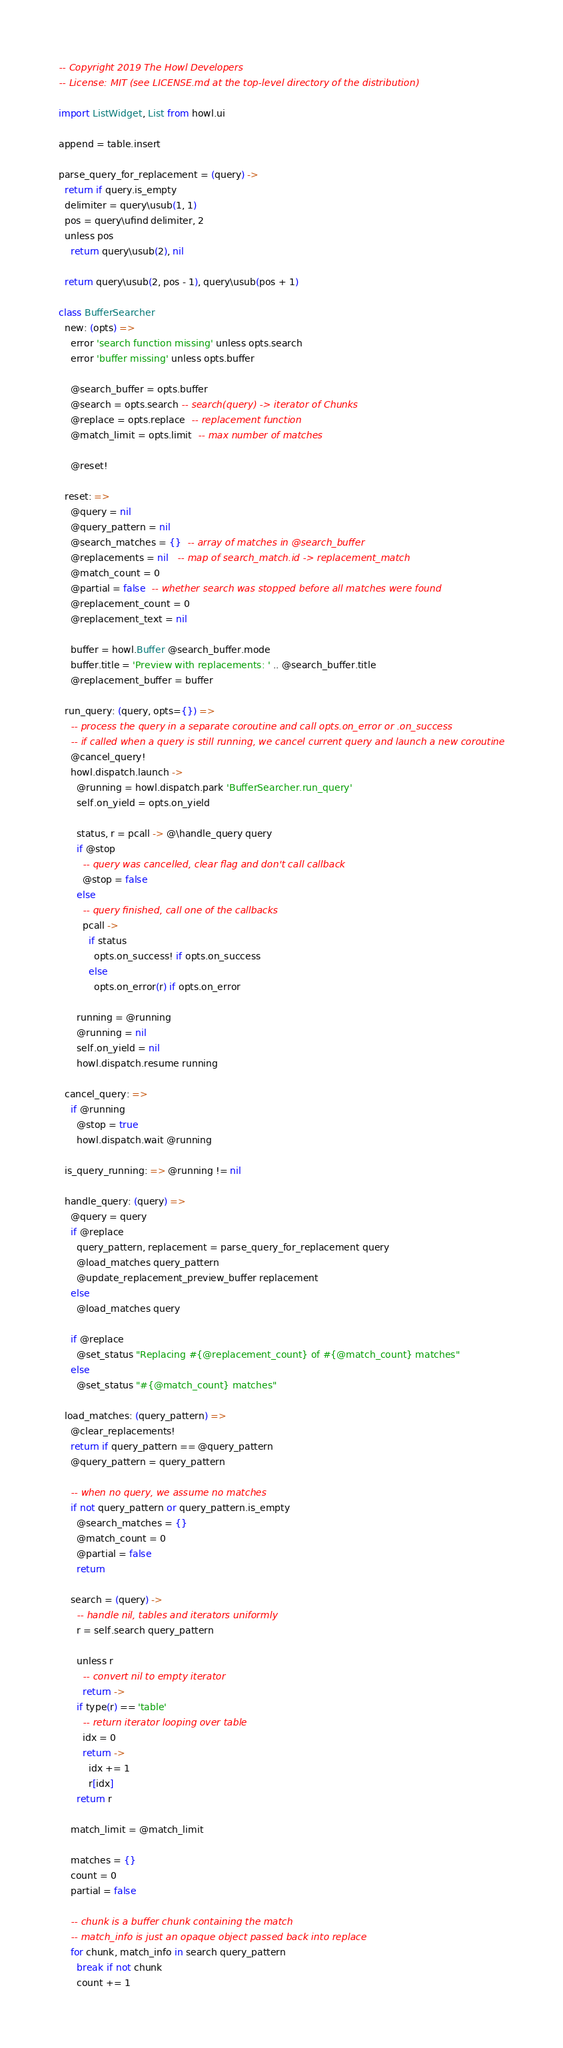Convert code to text. <code><loc_0><loc_0><loc_500><loc_500><_MoonScript_>-- Copyright 2019 The Howl Developers
-- License: MIT (see LICENSE.md at the top-level directory of the distribution)

import ListWidget, List from howl.ui

append = table.insert

parse_query_for_replacement = (query) ->
  return if query.is_empty
  delimiter = query\usub(1, 1)
  pos = query\ufind delimiter, 2
  unless pos
    return query\usub(2), nil

  return query\usub(2, pos - 1), query\usub(pos + 1)

class BufferSearcher
  new: (opts) =>
    error 'search function missing' unless opts.search
    error 'buffer missing' unless opts.buffer

    @search_buffer = opts.buffer
    @search = opts.search -- search(query) -> iterator of Chunks
    @replace = opts.replace  -- replacement function
    @match_limit = opts.limit  -- max number of matches

    @reset!

  reset: =>
    @query = nil
    @query_pattern = nil
    @search_matches = {}  -- array of matches in @search_buffer
    @replacements = nil   -- map of search_match.id -> replacement_match
    @match_count = 0
    @partial = false  -- whether search was stopped before all matches were found
    @replacement_count = 0
    @replacement_text = nil

    buffer = howl.Buffer @search_buffer.mode
    buffer.title = 'Preview with replacements: ' .. @search_buffer.title
    @replacement_buffer = buffer

  run_query: (query, opts={}) =>
    -- process the query in a separate coroutine and call opts.on_error or .on_success
    -- if called when a query is still running, we cancel current query and launch a new coroutine
    @cancel_query!
    howl.dispatch.launch ->
      @running = howl.dispatch.park 'BufferSearcher.run_query'
      self.on_yield = opts.on_yield

      status, r = pcall -> @\handle_query query
      if @stop
        -- query was cancelled, clear flag and don't call callback
        @stop = false
      else
        -- query finished, call one of the callbacks
        pcall ->
          if status
            opts.on_success! if opts.on_success
          else
            opts.on_error(r) if opts.on_error

      running = @running
      @running = nil
      self.on_yield = nil
      howl.dispatch.resume running

  cancel_query: =>
    if @running
      @stop = true
      howl.dispatch.wait @running

  is_query_running: => @running != nil

  handle_query: (query) =>
    @query = query
    if @replace
      query_pattern, replacement = parse_query_for_replacement query
      @load_matches query_pattern
      @update_replacement_preview_buffer replacement
    else
      @load_matches query

    if @replace
      @set_status "Replacing #{@replacement_count} of #{@match_count} matches"
    else
      @set_status "#{@match_count} matches"

  load_matches: (query_pattern) =>
    @clear_replacements!
    return if query_pattern == @query_pattern
    @query_pattern = query_pattern

    -- when no query, we assume no matches
    if not query_pattern or query_pattern.is_empty
      @search_matches = {}
      @match_count = 0
      @partial = false
      return

    search = (query) ->
      -- handle nil, tables and iterators uniformly
      r = self.search query_pattern

      unless r
        -- convert nil to empty iterator
        return ->
      if type(r) == 'table'
        -- return iterator looping over table
        idx = 0
        return ->
          idx += 1
          r[idx]
      return r

    match_limit = @match_limit

    matches = {}
    count = 0
    partial = false

    -- chunk is a buffer chunk containing the match
    -- match_info is just an opaque object passed back into replace
    for chunk, match_info in search query_pattern
      break if not chunk
      count += 1</code> 